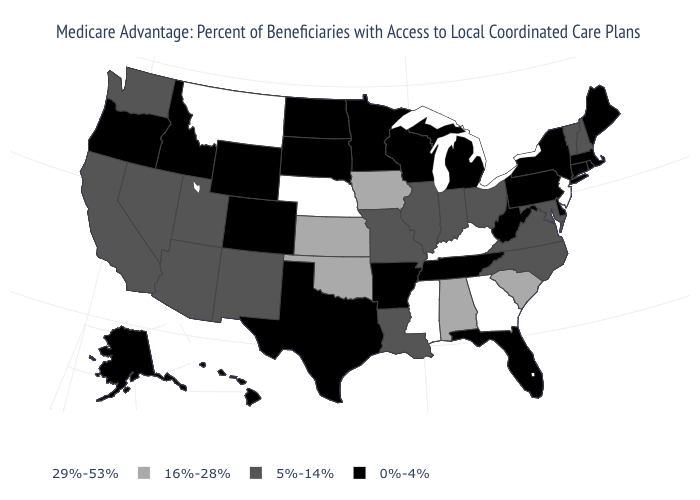Name the states that have a value in the range 5%-14%?
Write a very short answer. California, Illinois, Indiana, Louisiana, Maryland, Missouri, North Carolina, New Hampshire, New Mexico, Nevada, Ohio, Utah, Virginia, Vermont, Washington, Arizona. Name the states that have a value in the range 29%-53%?
Concise answer only. Georgia, Kentucky, Mississippi, Montana, Nebraska, New Jersey. What is the value of Hawaii?
Write a very short answer. 0%-4%. What is the value of South Dakota?
Be succinct. 0%-4%. Is the legend a continuous bar?
Give a very brief answer. No. How many symbols are there in the legend?
Keep it brief. 4. Does the first symbol in the legend represent the smallest category?
Keep it brief. No. What is the value of Oregon?
Keep it brief. 0%-4%. Does the first symbol in the legend represent the smallest category?
Short answer required. No. Does the map have missing data?
Keep it brief. No. Name the states that have a value in the range 29%-53%?
Keep it brief. Georgia, Kentucky, Mississippi, Montana, Nebraska, New Jersey. Does the first symbol in the legend represent the smallest category?
Give a very brief answer. No. Name the states that have a value in the range 29%-53%?
Answer briefly. Georgia, Kentucky, Mississippi, Montana, Nebraska, New Jersey. Which states have the highest value in the USA?
Be succinct. Georgia, Kentucky, Mississippi, Montana, Nebraska, New Jersey. Name the states that have a value in the range 0%-4%?
Short answer required. Colorado, Connecticut, Delaware, Florida, Hawaii, Idaho, Massachusetts, Maine, Michigan, Minnesota, North Dakota, New York, Oregon, Pennsylvania, Rhode Island, South Dakota, Alaska, Tennessee, Texas, Wisconsin, West Virginia, Wyoming, Arkansas. 